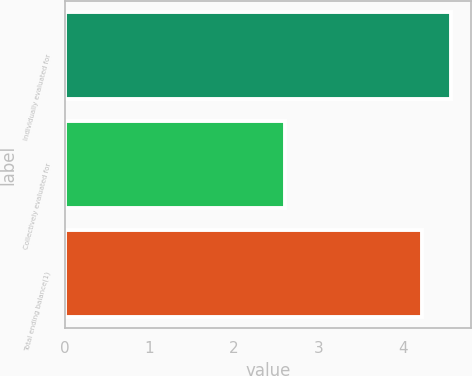Convert chart. <chart><loc_0><loc_0><loc_500><loc_500><bar_chart><fcel>Individually evaluated for<fcel>Collectively evaluated for<fcel>Total ending balance(1)<nl><fcel>4.57<fcel>2.6<fcel>4.22<nl></chart> 